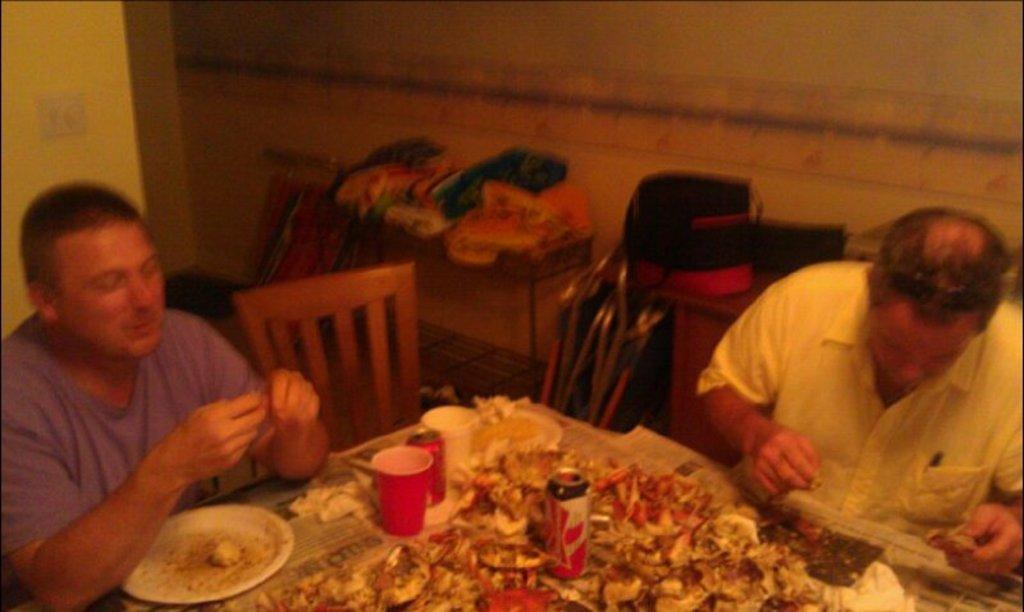In one or two sentences, can you explain what this image depicts? This picture is inside view of a room. In the center of the image we can see a table. On table there is a coke bottle, glasses, plate, paper are present. On the left and right side of the image two persons are sitting on a chair. In the background of the image we can see the bag, clothes, table, chair, stand are present. At the top of the image wall is there. In the middle of the image floor is present. 